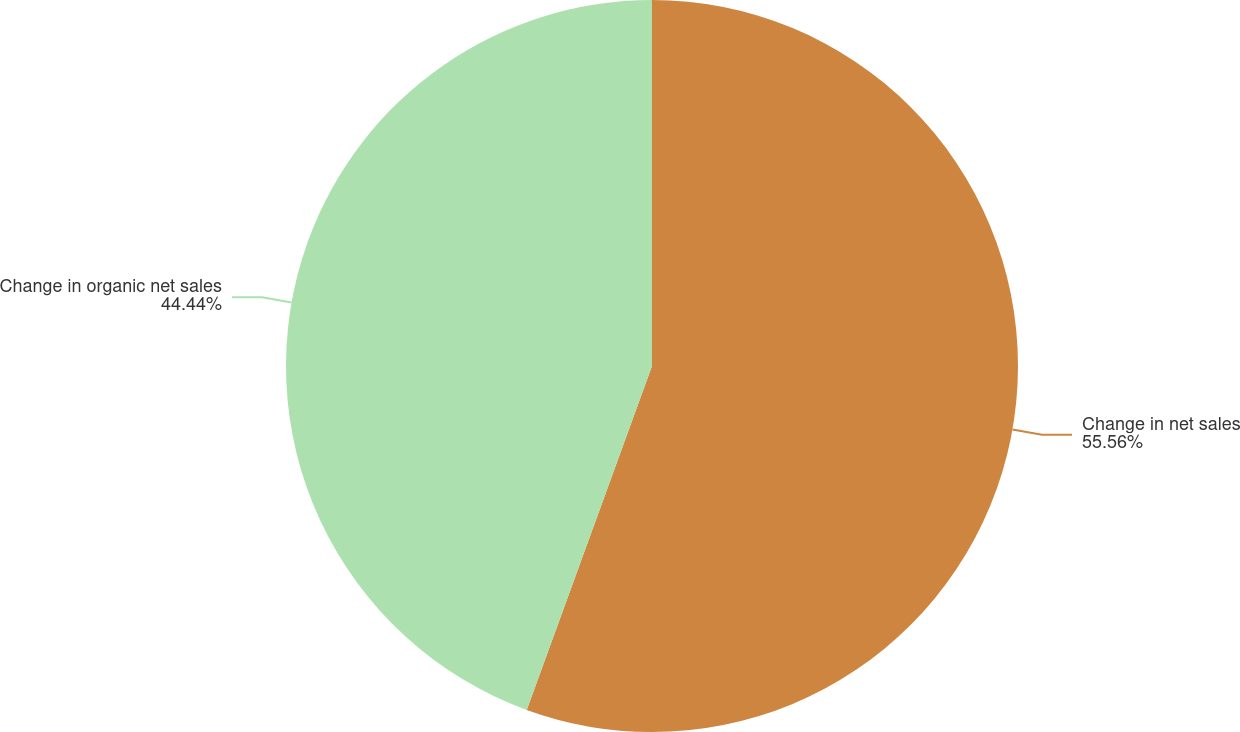Convert chart. <chart><loc_0><loc_0><loc_500><loc_500><pie_chart><fcel>Change in net sales<fcel>Change in organic net sales<nl><fcel>55.56%<fcel>44.44%<nl></chart> 